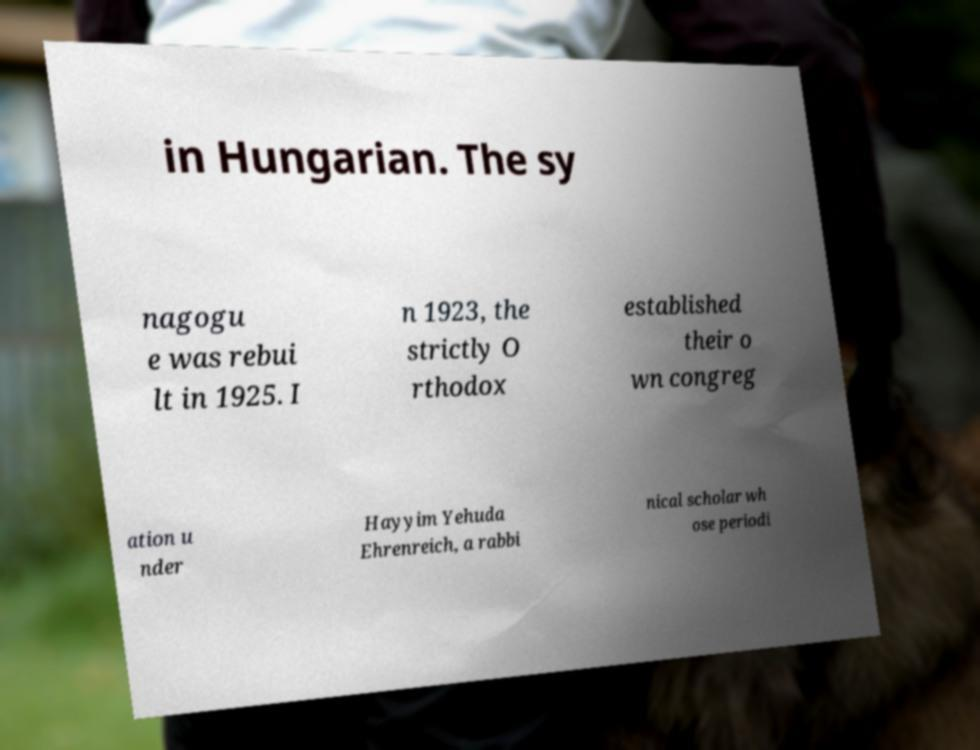I need the written content from this picture converted into text. Can you do that? in Hungarian. The sy nagogu e was rebui lt in 1925. I n 1923, the strictly O rthodox established their o wn congreg ation u nder Hayyim Yehuda Ehrenreich, a rabbi nical scholar wh ose periodi 